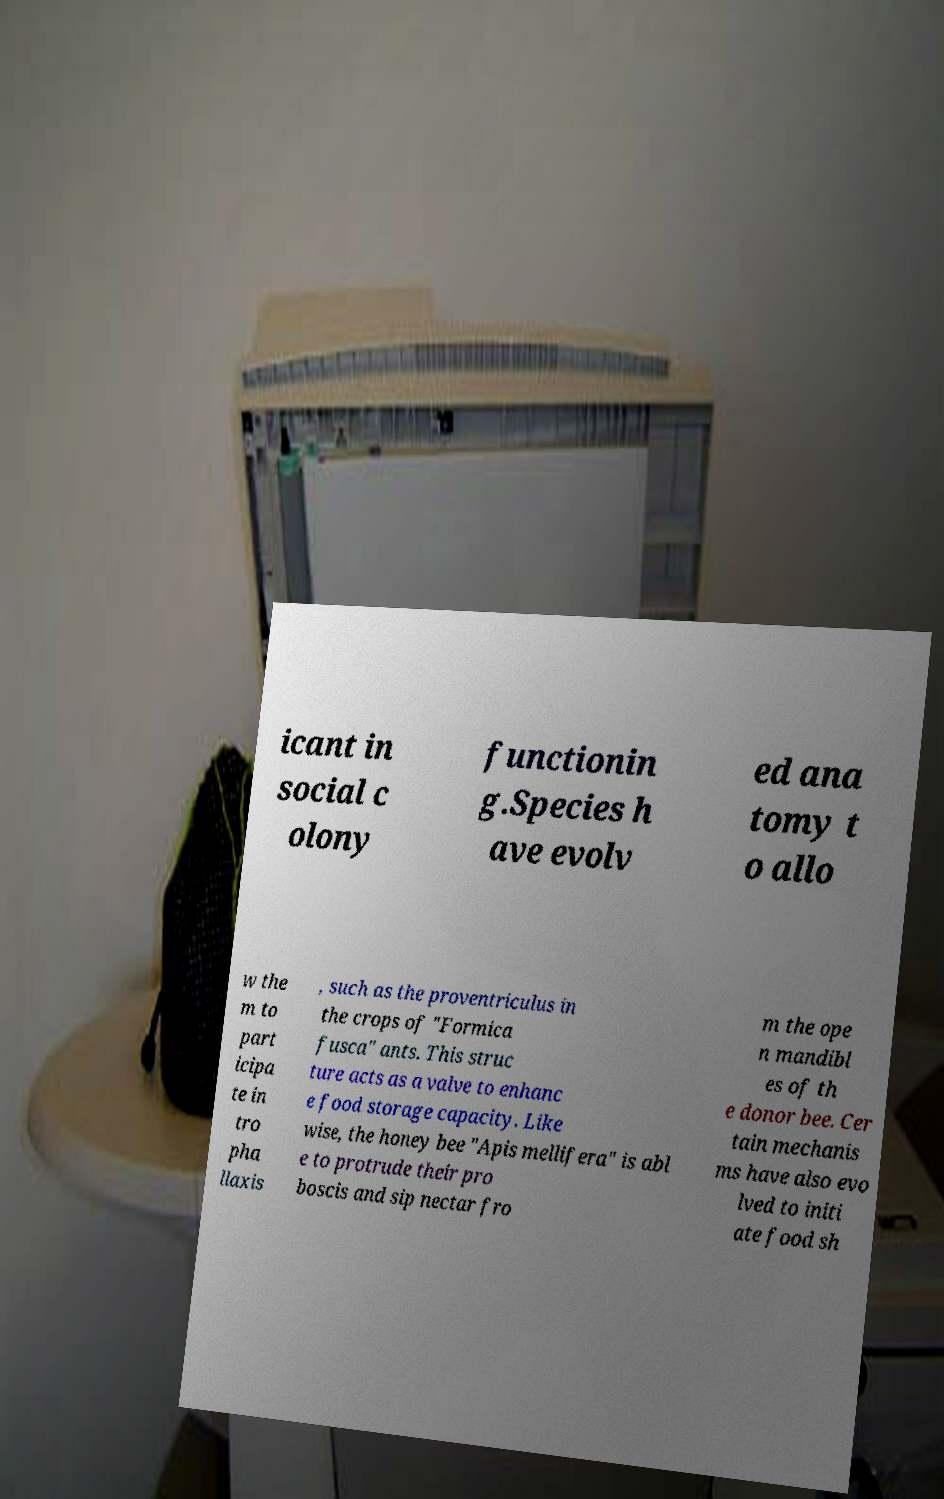What messages or text are displayed in this image? I need them in a readable, typed format. icant in social c olony functionin g.Species h ave evolv ed ana tomy t o allo w the m to part icipa te in tro pha llaxis , such as the proventriculus in the crops of "Formica fusca" ants. This struc ture acts as a valve to enhanc e food storage capacity. Like wise, the honey bee "Apis mellifera" is abl e to protrude their pro boscis and sip nectar fro m the ope n mandibl es of th e donor bee. Cer tain mechanis ms have also evo lved to initi ate food sh 